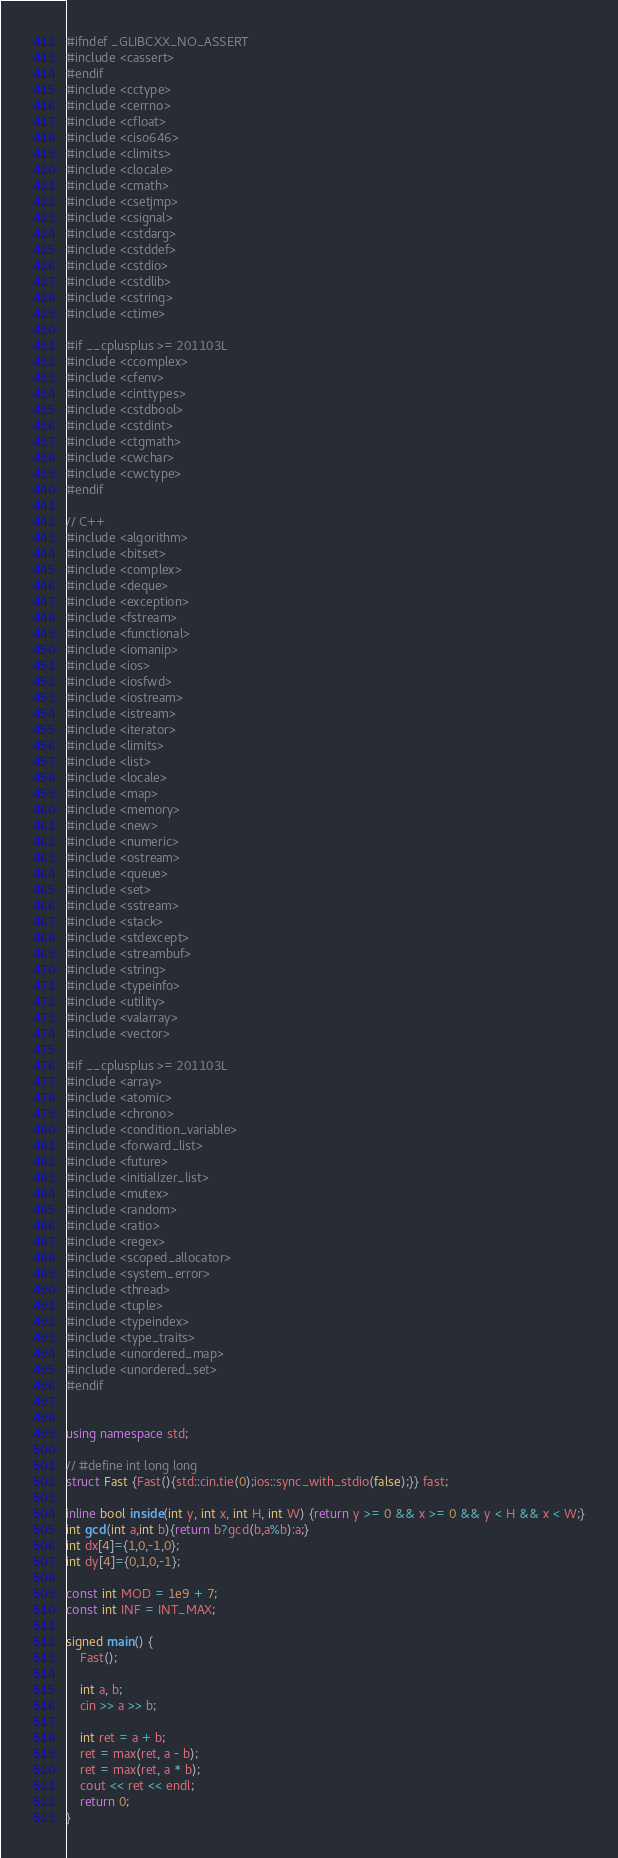Convert code to text. <code><loc_0><loc_0><loc_500><loc_500><_C++_>#ifndef _GLIBCXX_NO_ASSERT
#include <cassert>
#endif
#include <cctype>
#include <cerrno>
#include <cfloat>
#include <ciso646>
#include <climits>
#include <clocale>
#include <cmath>
#include <csetjmp>
#include <csignal>
#include <cstdarg>
#include <cstddef>
#include <cstdio>
#include <cstdlib>
#include <cstring>
#include <ctime>

#if __cplusplus >= 201103L
#include <ccomplex>
#include <cfenv>
#include <cinttypes>
#include <cstdbool>
#include <cstdint>
#include <ctgmath>
#include <cwchar>
#include <cwctype>
#endif

// C++
#include <algorithm>
#include <bitset>
#include <complex>
#include <deque>
#include <exception>
#include <fstream>
#include <functional>
#include <iomanip>
#include <ios>
#include <iosfwd>
#include <iostream>
#include <istream>
#include <iterator>
#include <limits>
#include <list>
#include <locale>
#include <map>
#include <memory>
#include <new>
#include <numeric>
#include <ostream>
#include <queue>
#include <set>
#include <sstream>
#include <stack>
#include <stdexcept>
#include <streambuf>
#include <string>
#include <typeinfo>
#include <utility>
#include <valarray>
#include <vector>

#if __cplusplus >= 201103L
#include <array>
#include <atomic>
#include <chrono>
#include <condition_variable>
#include <forward_list>
#include <future>
#include <initializer_list>
#include <mutex>
#include <random>
#include <ratio>
#include <regex>
#include <scoped_allocator>
#include <system_error>
#include <thread>
#include <tuple>
#include <typeindex>
#include <type_traits>
#include <unordered_map>
#include <unordered_set>
#endif


using namespace std;

// #define int long long
struct Fast {Fast(){std::cin.tie(0);ios::sync_with_stdio(false);}} fast;

inline bool inside(int y, int x, int H, int W) {return y >= 0 && x >= 0 && y < H && x < W;}
int gcd(int a,int b){return b?gcd(b,a%b):a;}
int dx[4]={1,0,-1,0};
int dy[4]={0,1,0,-1};

const int MOD = 1e9 + 7;
const int INF = INT_MAX;

signed main() {
    Fast();

    int a, b;
    cin >> a >> b;

    int ret = a + b;
    ret = max(ret, a - b);
    ret = max(ret, a * b);
    cout << ret << endl;
    return 0;
}

</code> 